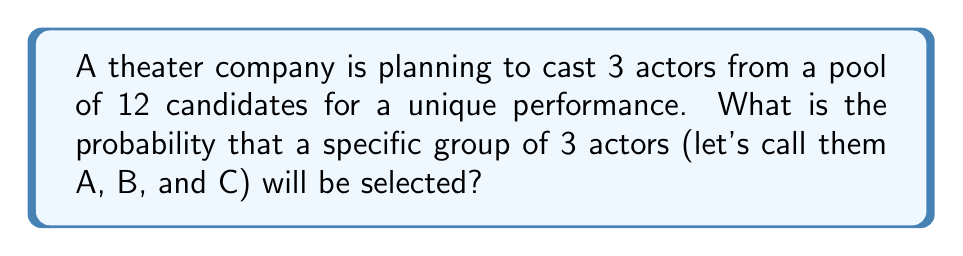Can you answer this question? Let's approach this step-by-step using combinatorial techniques:

1) First, we need to calculate the total number of possible ways to select 3 actors from 12 candidates. This is a combination problem, denoted as $\binom{12}{3}$ or $C(12,3)$.

2) The formula for this combination is:

   $$\binom{12}{3} = \frac{12!}{3!(12-3)!} = \frac{12!}{3!9!}$$

3) Calculating this:
   $$\frac{12 \cdot 11 \cdot 10 \cdot 9!}{(3 \cdot 2 \cdot 1) \cdot 9!} = \frac{1320}{6} = 220$$

4) So there are 220 possible ways to select 3 actors from 12 candidates.

5) Now, for the probability of selecting the specific group (A, B, and C), there is only one way to select this exact group.

6) In probability, when all outcomes are equally likely, the probability of an event is the number of favorable outcomes divided by the total number of possible outcomes.

7) In this case:
   Probability = $\frac{\text{Number of ways to select A, B, and C}}{\text{Total number of ways to select 3 from 12}}$

   $$P(\text{selecting A, B, and C}) = \frac{1}{220}$$
Answer: $\frac{1}{220}$ 